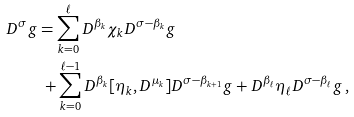<formula> <loc_0><loc_0><loc_500><loc_500>D ^ { \sigma } g & = \sum _ { k = 0 } ^ { \ell } D ^ { \beta _ { k } } \chi _ { k } D ^ { \sigma - \beta _ { k } } g \\ & { \ } + \sum _ { k = 0 } ^ { \ell - 1 } D ^ { \beta _ { k } } [ \eta _ { k } , D ^ { \mu _ { k } } ] D ^ { \sigma - \beta _ { k + 1 } } g + D ^ { \beta _ { \ell } } \eta _ { \ell } D ^ { \sigma - \beta _ { \ell } } g \, ,</formula> 